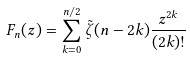<formula> <loc_0><loc_0><loc_500><loc_500>F _ { n } ( z ) = \sum _ { k = 0 } ^ { n / 2 } \tilde { \zeta } ( n - 2 k ) \frac { z ^ { 2 k } } { ( 2 k ) ! }</formula> 